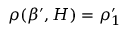Convert formula to latex. <formula><loc_0><loc_0><loc_500><loc_500>\rho ( \beta ^ { \prime } , H ) = \rho _ { 1 } ^ { \prime }</formula> 